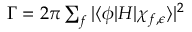Convert formula to latex. <formula><loc_0><loc_0><loc_500><loc_500>\begin{array} { r } { \Gamma = 2 \pi \sum _ { f } | \langle \phi | H | \chi _ { f , \epsilon } \rangle | ^ { 2 } } \end{array}</formula> 